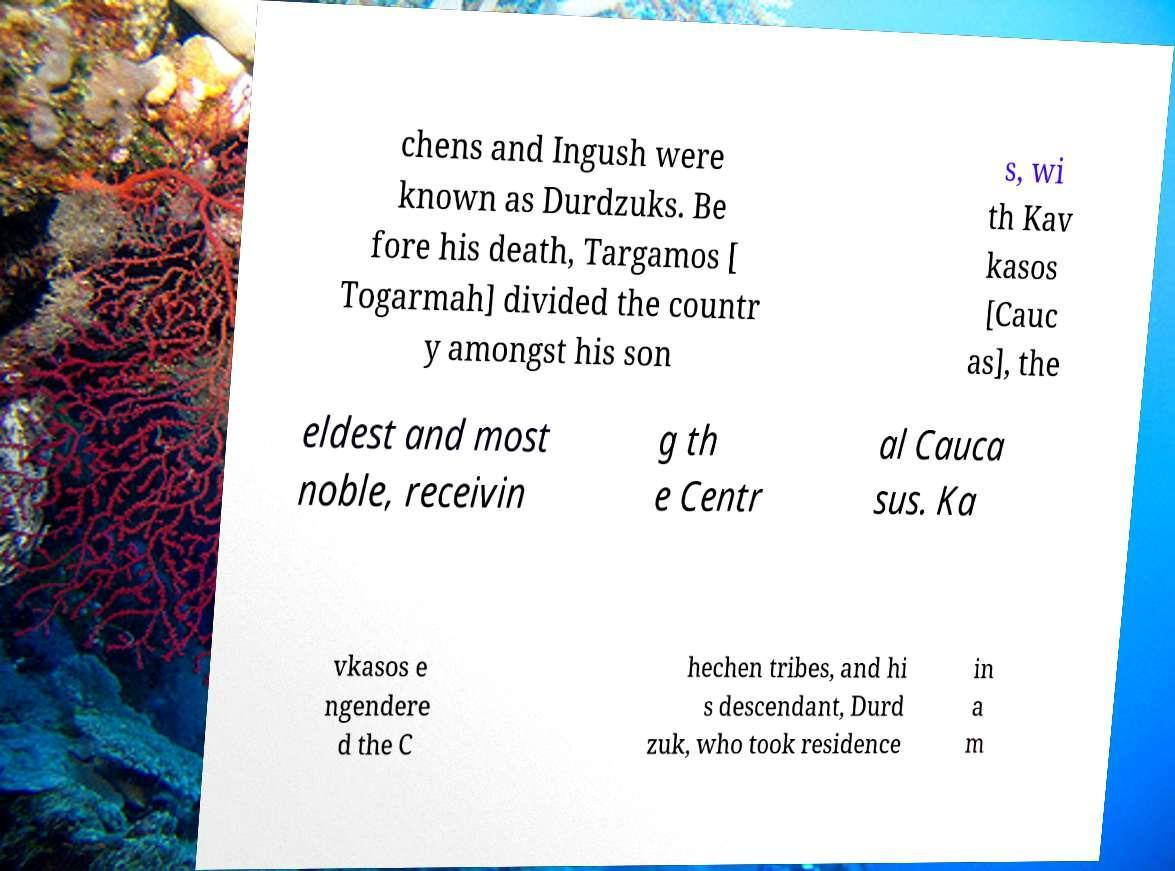For documentation purposes, I need the text within this image transcribed. Could you provide that? chens and Ingush were known as Durdzuks. Be fore his death, Targamos [ Togarmah] divided the countr y amongst his son s, wi th Kav kasos [Cauc as], the eldest and most noble, receivin g th e Centr al Cauca sus. Ka vkasos e ngendere d the C hechen tribes, and hi s descendant, Durd zuk, who took residence in a m 